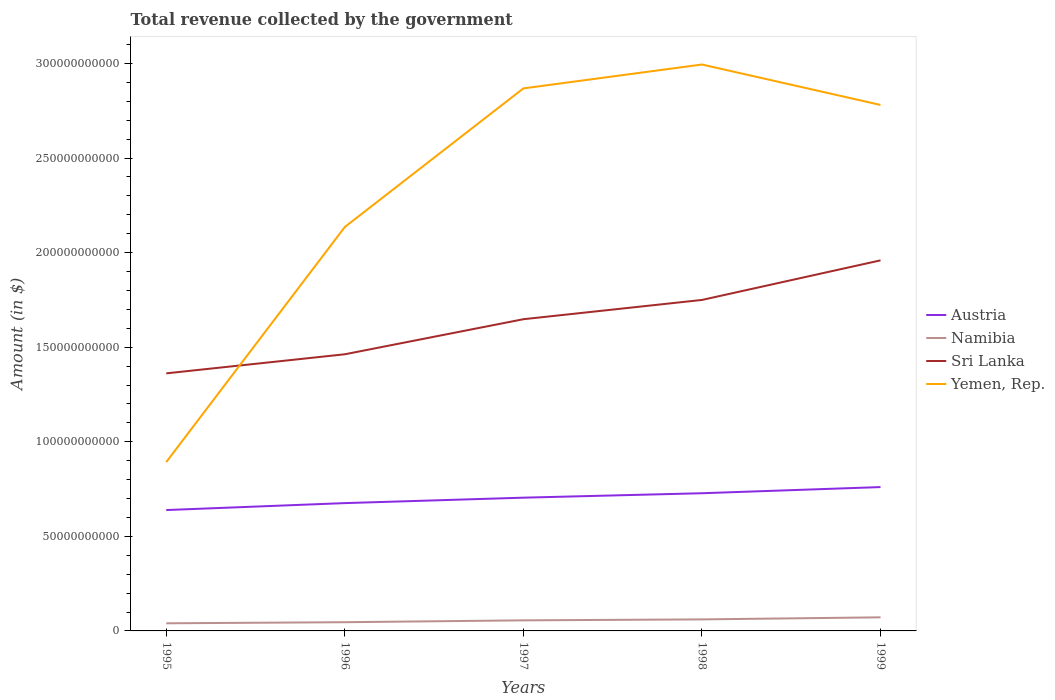How many different coloured lines are there?
Your answer should be very brief. 4. Across all years, what is the maximum total revenue collected by the government in Yemen, Rep.?
Make the answer very short. 8.93e+1. What is the total total revenue collected by the government in Namibia in the graph?
Ensure brevity in your answer.  -9.80e+08. What is the difference between the highest and the second highest total revenue collected by the government in Sri Lanka?
Your answer should be compact. 5.97e+1. How many lines are there?
Your answer should be compact. 4. How many years are there in the graph?
Your response must be concise. 5. What is the difference between two consecutive major ticks on the Y-axis?
Provide a succinct answer. 5.00e+1. Are the values on the major ticks of Y-axis written in scientific E-notation?
Provide a short and direct response. No. Does the graph contain grids?
Your answer should be compact. No. Where does the legend appear in the graph?
Provide a succinct answer. Center right. How are the legend labels stacked?
Your answer should be compact. Vertical. What is the title of the graph?
Your response must be concise. Total revenue collected by the government. What is the label or title of the X-axis?
Your answer should be very brief. Years. What is the label or title of the Y-axis?
Offer a terse response. Amount (in $). What is the Amount (in $) of Austria in 1995?
Offer a very short reply. 6.39e+1. What is the Amount (in $) of Namibia in 1995?
Your answer should be very brief. 4.03e+09. What is the Amount (in $) of Sri Lanka in 1995?
Offer a very short reply. 1.36e+11. What is the Amount (in $) in Yemen, Rep. in 1995?
Make the answer very short. 8.93e+1. What is the Amount (in $) in Austria in 1996?
Offer a very short reply. 6.76e+1. What is the Amount (in $) in Namibia in 1996?
Offer a terse response. 4.61e+09. What is the Amount (in $) of Sri Lanka in 1996?
Give a very brief answer. 1.46e+11. What is the Amount (in $) of Yemen, Rep. in 1996?
Provide a succinct answer. 2.14e+11. What is the Amount (in $) of Austria in 1997?
Provide a succinct answer. 7.04e+1. What is the Amount (in $) in Namibia in 1997?
Ensure brevity in your answer.  5.59e+09. What is the Amount (in $) of Sri Lanka in 1997?
Your answer should be very brief. 1.65e+11. What is the Amount (in $) of Yemen, Rep. in 1997?
Your answer should be very brief. 2.87e+11. What is the Amount (in $) in Austria in 1998?
Your answer should be compact. 7.28e+1. What is the Amount (in $) of Namibia in 1998?
Your answer should be compact. 6.09e+09. What is the Amount (in $) of Sri Lanka in 1998?
Provide a succinct answer. 1.75e+11. What is the Amount (in $) in Yemen, Rep. in 1998?
Offer a very short reply. 2.99e+11. What is the Amount (in $) in Austria in 1999?
Give a very brief answer. 7.60e+1. What is the Amount (in $) in Namibia in 1999?
Provide a short and direct response. 7.18e+09. What is the Amount (in $) in Sri Lanka in 1999?
Give a very brief answer. 1.96e+11. What is the Amount (in $) of Yemen, Rep. in 1999?
Provide a short and direct response. 2.78e+11. Across all years, what is the maximum Amount (in $) of Austria?
Ensure brevity in your answer.  7.60e+1. Across all years, what is the maximum Amount (in $) of Namibia?
Provide a short and direct response. 7.18e+09. Across all years, what is the maximum Amount (in $) of Sri Lanka?
Offer a very short reply. 1.96e+11. Across all years, what is the maximum Amount (in $) of Yemen, Rep.?
Provide a succinct answer. 2.99e+11. Across all years, what is the minimum Amount (in $) in Austria?
Keep it short and to the point. 6.39e+1. Across all years, what is the minimum Amount (in $) of Namibia?
Keep it short and to the point. 4.03e+09. Across all years, what is the minimum Amount (in $) in Sri Lanka?
Give a very brief answer. 1.36e+11. Across all years, what is the minimum Amount (in $) of Yemen, Rep.?
Keep it short and to the point. 8.93e+1. What is the total Amount (in $) in Austria in the graph?
Ensure brevity in your answer.  3.51e+11. What is the total Amount (in $) of Namibia in the graph?
Make the answer very short. 2.75e+1. What is the total Amount (in $) of Sri Lanka in the graph?
Provide a succinct answer. 8.18e+11. What is the total Amount (in $) in Yemen, Rep. in the graph?
Your answer should be very brief. 1.17e+12. What is the difference between the Amount (in $) of Austria in 1995 and that in 1996?
Provide a succinct answer. -3.67e+09. What is the difference between the Amount (in $) of Namibia in 1995 and that in 1996?
Give a very brief answer. -5.83e+08. What is the difference between the Amount (in $) in Sri Lanka in 1995 and that in 1996?
Offer a terse response. -1.01e+1. What is the difference between the Amount (in $) of Yemen, Rep. in 1995 and that in 1996?
Your response must be concise. -1.24e+11. What is the difference between the Amount (in $) of Austria in 1995 and that in 1997?
Your response must be concise. -6.54e+09. What is the difference between the Amount (in $) in Namibia in 1995 and that in 1997?
Keep it short and to the point. -1.56e+09. What is the difference between the Amount (in $) in Sri Lanka in 1995 and that in 1997?
Make the answer very short. -2.86e+1. What is the difference between the Amount (in $) in Yemen, Rep. in 1995 and that in 1997?
Make the answer very short. -1.98e+11. What is the difference between the Amount (in $) of Austria in 1995 and that in 1998?
Your answer should be very brief. -8.89e+09. What is the difference between the Amount (in $) of Namibia in 1995 and that in 1998?
Your response must be concise. -2.07e+09. What is the difference between the Amount (in $) in Sri Lanka in 1995 and that in 1998?
Keep it short and to the point. -3.88e+1. What is the difference between the Amount (in $) of Yemen, Rep. in 1995 and that in 1998?
Ensure brevity in your answer.  -2.10e+11. What is the difference between the Amount (in $) in Austria in 1995 and that in 1999?
Keep it short and to the point. -1.21e+1. What is the difference between the Amount (in $) of Namibia in 1995 and that in 1999?
Offer a very short reply. -3.16e+09. What is the difference between the Amount (in $) of Sri Lanka in 1995 and that in 1999?
Your answer should be compact. -5.97e+1. What is the difference between the Amount (in $) of Yemen, Rep. in 1995 and that in 1999?
Offer a terse response. -1.89e+11. What is the difference between the Amount (in $) of Austria in 1996 and that in 1997?
Your answer should be very brief. -2.87e+09. What is the difference between the Amount (in $) of Namibia in 1996 and that in 1997?
Keep it short and to the point. -9.80e+08. What is the difference between the Amount (in $) of Sri Lanka in 1996 and that in 1997?
Your response must be concise. -1.85e+1. What is the difference between the Amount (in $) in Yemen, Rep. in 1996 and that in 1997?
Keep it short and to the point. -7.33e+1. What is the difference between the Amount (in $) in Austria in 1996 and that in 1998?
Provide a succinct answer. -5.22e+09. What is the difference between the Amount (in $) in Namibia in 1996 and that in 1998?
Your answer should be very brief. -1.48e+09. What is the difference between the Amount (in $) of Sri Lanka in 1996 and that in 1998?
Offer a very short reply. -2.87e+1. What is the difference between the Amount (in $) in Yemen, Rep. in 1996 and that in 1998?
Provide a short and direct response. -8.59e+1. What is the difference between the Amount (in $) of Austria in 1996 and that in 1999?
Ensure brevity in your answer.  -8.47e+09. What is the difference between the Amount (in $) in Namibia in 1996 and that in 1999?
Provide a short and direct response. -2.57e+09. What is the difference between the Amount (in $) of Sri Lanka in 1996 and that in 1999?
Give a very brief answer. -4.96e+1. What is the difference between the Amount (in $) in Yemen, Rep. in 1996 and that in 1999?
Provide a short and direct response. -6.45e+1. What is the difference between the Amount (in $) in Austria in 1997 and that in 1998?
Give a very brief answer. -2.35e+09. What is the difference between the Amount (in $) of Namibia in 1997 and that in 1998?
Provide a succinct answer. -5.03e+08. What is the difference between the Amount (in $) in Sri Lanka in 1997 and that in 1998?
Offer a terse response. -1.02e+1. What is the difference between the Amount (in $) in Yemen, Rep. in 1997 and that in 1998?
Give a very brief answer. -1.26e+1. What is the difference between the Amount (in $) in Austria in 1997 and that in 1999?
Keep it short and to the point. -5.60e+09. What is the difference between the Amount (in $) in Namibia in 1997 and that in 1999?
Provide a short and direct response. -1.59e+09. What is the difference between the Amount (in $) in Sri Lanka in 1997 and that in 1999?
Your answer should be compact. -3.11e+1. What is the difference between the Amount (in $) of Yemen, Rep. in 1997 and that in 1999?
Make the answer very short. 8.75e+09. What is the difference between the Amount (in $) of Austria in 1998 and that in 1999?
Give a very brief answer. -3.25e+09. What is the difference between the Amount (in $) of Namibia in 1998 and that in 1999?
Make the answer very short. -1.09e+09. What is the difference between the Amount (in $) of Sri Lanka in 1998 and that in 1999?
Keep it short and to the point. -2.09e+1. What is the difference between the Amount (in $) of Yemen, Rep. in 1998 and that in 1999?
Keep it short and to the point. 2.14e+1. What is the difference between the Amount (in $) of Austria in 1995 and the Amount (in $) of Namibia in 1996?
Give a very brief answer. 5.93e+1. What is the difference between the Amount (in $) of Austria in 1995 and the Amount (in $) of Sri Lanka in 1996?
Offer a terse response. -8.23e+1. What is the difference between the Amount (in $) in Austria in 1995 and the Amount (in $) in Yemen, Rep. in 1996?
Keep it short and to the point. -1.50e+11. What is the difference between the Amount (in $) in Namibia in 1995 and the Amount (in $) in Sri Lanka in 1996?
Provide a short and direct response. -1.42e+11. What is the difference between the Amount (in $) in Namibia in 1995 and the Amount (in $) in Yemen, Rep. in 1996?
Keep it short and to the point. -2.10e+11. What is the difference between the Amount (in $) of Sri Lanka in 1995 and the Amount (in $) of Yemen, Rep. in 1996?
Give a very brief answer. -7.74e+1. What is the difference between the Amount (in $) of Austria in 1995 and the Amount (in $) of Namibia in 1997?
Make the answer very short. 5.83e+1. What is the difference between the Amount (in $) in Austria in 1995 and the Amount (in $) in Sri Lanka in 1997?
Offer a terse response. -1.01e+11. What is the difference between the Amount (in $) of Austria in 1995 and the Amount (in $) of Yemen, Rep. in 1997?
Provide a short and direct response. -2.23e+11. What is the difference between the Amount (in $) in Namibia in 1995 and the Amount (in $) in Sri Lanka in 1997?
Your response must be concise. -1.61e+11. What is the difference between the Amount (in $) of Namibia in 1995 and the Amount (in $) of Yemen, Rep. in 1997?
Keep it short and to the point. -2.83e+11. What is the difference between the Amount (in $) in Sri Lanka in 1995 and the Amount (in $) in Yemen, Rep. in 1997?
Offer a very short reply. -1.51e+11. What is the difference between the Amount (in $) of Austria in 1995 and the Amount (in $) of Namibia in 1998?
Keep it short and to the point. 5.78e+1. What is the difference between the Amount (in $) in Austria in 1995 and the Amount (in $) in Sri Lanka in 1998?
Your response must be concise. -1.11e+11. What is the difference between the Amount (in $) of Austria in 1995 and the Amount (in $) of Yemen, Rep. in 1998?
Your answer should be compact. -2.36e+11. What is the difference between the Amount (in $) in Namibia in 1995 and the Amount (in $) in Sri Lanka in 1998?
Your answer should be compact. -1.71e+11. What is the difference between the Amount (in $) in Namibia in 1995 and the Amount (in $) in Yemen, Rep. in 1998?
Provide a succinct answer. -2.95e+11. What is the difference between the Amount (in $) of Sri Lanka in 1995 and the Amount (in $) of Yemen, Rep. in 1998?
Provide a succinct answer. -1.63e+11. What is the difference between the Amount (in $) of Austria in 1995 and the Amount (in $) of Namibia in 1999?
Your answer should be very brief. 5.67e+1. What is the difference between the Amount (in $) of Austria in 1995 and the Amount (in $) of Sri Lanka in 1999?
Your answer should be compact. -1.32e+11. What is the difference between the Amount (in $) in Austria in 1995 and the Amount (in $) in Yemen, Rep. in 1999?
Your answer should be very brief. -2.14e+11. What is the difference between the Amount (in $) in Namibia in 1995 and the Amount (in $) in Sri Lanka in 1999?
Provide a short and direct response. -1.92e+11. What is the difference between the Amount (in $) in Namibia in 1995 and the Amount (in $) in Yemen, Rep. in 1999?
Ensure brevity in your answer.  -2.74e+11. What is the difference between the Amount (in $) in Sri Lanka in 1995 and the Amount (in $) in Yemen, Rep. in 1999?
Keep it short and to the point. -1.42e+11. What is the difference between the Amount (in $) in Austria in 1996 and the Amount (in $) in Namibia in 1997?
Provide a succinct answer. 6.20e+1. What is the difference between the Amount (in $) in Austria in 1996 and the Amount (in $) in Sri Lanka in 1997?
Offer a very short reply. -9.72e+1. What is the difference between the Amount (in $) of Austria in 1996 and the Amount (in $) of Yemen, Rep. in 1997?
Provide a succinct answer. -2.19e+11. What is the difference between the Amount (in $) of Namibia in 1996 and the Amount (in $) of Sri Lanka in 1997?
Provide a succinct answer. -1.60e+11. What is the difference between the Amount (in $) in Namibia in 1996 and the Amount (in $) in Yemen, Rep. in 1997?
Offer a very short reply. -2.82e+11. What is the difference between the Amount (in $) in Sri Lanka in 1996 and the Amount (in $) in Yemen, Rep. in 1997?
Offer a very short reply. -1.41e+11. What is the difference between the Amount (in $) of Austria in 1996 and the Amount (in $) of Namibia in 1998?
Provide a succinct answer. 6.15e+1. What is the difference between the Amount (in $) in Austria in 1996 and the Amount (in $) in Sri Lanka in 1998?
Offer a terse response. -1.07e+11. What is the difference between the Amount (in $) of Austria in 1996 and the Amount (in $) of Yemen, Rep. in 1998?
Your response must be concise. -2.32e+11. What is the difference between the Amount (in $) of Namibia in 1996 and the Amount (in $) of Sri Lanka in 1998?
Keep it short and to the point. -1.70e+11. What is the difference between the Amount (in $) of Namibia in 1996 and the Amount (in $) of Yemen, Rep. in 1998?
Keep it short and to the point. -2.95e+11. What is the difference between the Amount (in $) in Sri Lanka in 1996 and the Amount (in $) in Yemen, Rep. in 1998?
Your answer should be compact. -1.53e+11. What is the difference between the Amount (in $) in Austria in 1996 and the Amount (in $) in Namibia in 1999?
Make the answer very short. 6.04e+1. What is the difference between the Amount (in $) in Austria in 1996 and the Amount (in $) in Sri Lanka in 1999?
Ensure brevity in your answer.  -1.28e+11. What is the difference between the Amount (in $) in Austria in 1996 and the Amount (in $) in Yemen, Rep. in 1999?
Give a very brief answer. -2.10e+11. What is the difference between the Amount (in $) of Namibia in 1996 and the Amount (in $) of Sri Lanka in 1999?
Your response must be concise. -1.91e+11. What is the difference between the Amount (in $) of Namibia in 1996 and the Amount (in $) of Yemen, Rep. in 1999?
Keep it short and to the point. -2.73e+11. What is the difference between the Amount (in $) of Sri Lanka in 1996 and the Amount (in $) of Yemen, Rep. in 1999?
Keep it short and to the point. -1.32e+11. What is the difference between the Amount (in $) in Austria in 1997 and the Amount (in $) in Namibia in 1998?
Provide a succinct answer. 6.43e+1. What is the difference between the Amount (in $) of Austria in 1997 and the Amount (in $) of Sri Lanka in 1998?
Provide a succinct answer. -1.05e+11. What is the difference between the Amount (in $) in Austria in 1997 and the Amount (in $) in Yemen, Rep. in 1998?
Offer a very short reply. -2.29e+11. What is the difference between the Amount (in $) of Namibia in 1997 and the Amount (in $) of Sri Lanka in 1998?
Provide a succinct answer. -1.69e+11. What is the difference between the Amount (in $) in Namibia in 1997 and the Amount (in $) in Yemen, Rep. in 1998?
Give a very brief answer. -2.94e+11. What is the difference between the Amount (in $) in Sri Lanka in 1997 and the Amount (in $) in Yemen, Rep. in 1998?
Your answer should be compact. -1.35e+11. What is the difference between the Amount (in $) of Austria in 1997 and the Amount (in $) of Namibia in 1999?
Ensure brevity in your answer.  6.33e+1. What is the difference between the Amount (in $) of Austria in 1997 and the Amount (in $) of Sri Lanka in 1999?
Give a very brief answer. -1.25e+11. What is the difference between the Amount (in $) in Austria in 1997 and the Amount (in $) in Yemen, Rep. in 1999?
Provide a short and direct response. -2.08e+11. What is the difference between the Amount (in $) of Namibia in 1997 and the Amount (in $) of Sri Lanka in 1999?
Offer a very short reply. -1.90e+11. What is the difference between the Amount (in $) in Namibia in 1997 and the Amount (in $) in Yemen, Rep. in 1999?
Your answer should be very brief. -2.72e+11. What is the difference between the Amount (in $) of Sri Lanka in 1997 and the Amount (in $) of Yemen, Rep. in 1999?
Give a very brief answer. -1.13e+11. What is the difference between the Amount (in $) in Austria in 1998 and the Amount (in $) in Namibia in 1999?
Provide a succinct answer. 6.56e+1. What is the difference between the Amount (in $) of Austria in 1998 and the Amount (in $) of Sri Lanka in 1999?
Ensure brevity in your answer.  -1.23e+11. What is the difference between the Amount (in $) of Austria in 1998 and the Amount (in $) of Yemen, Rep. in 1999?
Keep it short and to the point. -2.05e+11. What is the difference between the Amount (in $) in Namibia in 1998 and the Amount (in $) in Sri Lanka in 1999?
Give a very brief answer. -1.90e+11. What is the difference between the Amount (in $) in Namibia in 1998 and the Amount (in $) in Yemen, Rep. in 1999?
Offer a terse response. -2.72e+11. What is the difference between the Amount (in $) of Sri Lanka in 1998 and the Amount (in $) of Yemen, Rep. in 1999?
Your answer should be very brief. -1.03e+11. What is the average Amount (in $) of Austria per year?
Offer a very short reply. 7.01e+1. What is the average Amount (in $) in Namibia per year?
Make the answer very short. 5.50e+09. What is the average Amount (in $) in Sri Lanka per year?
Give a very brief answer. 1.64e+11. What is the average Amount (in $) in Yemen, Rep. per year?
Your answer should be very brief. 2.33e+11. In the year 1995, what is the difference between the Amount (in $) of Austria and Amount (in $) of Namibia?
Ensure brevity in your answer.  5.99e+1. In the year 1995, what is the difference between the Amount (in $) of Austria and Amount (in $) of Sri Lanka?
Ensure brevity in your answer.  -7.23e+1. In the year 1995, what is the difference between the Amount (in $) in Austria and Amount (in $) in Yemen, Rep.?
Your answer should be very brief. -2.54e+1. In the year 1995, what is the difference between the Amount (in $) in Namibia and Amount (in $) in Sri Lanka?
Keep it short and to the point. -1.32e+11. In the year 1995, what is the difference between the Amount (in $) in Namibia and Amount (in $) in Yemen, Rep.?
Your answer should be compact. -8.52e+1. In the year 1995, what is the difference between the Amount (in $) in Sri Lanka and Amount (in $) in Yemen, Rep.?
Ensure brevity in your answer.  4.69e+1. In the year 1996, what is the difference between the Amount (in $) in Austria and Amount (in $) in Namibia?
Make the answer very short. 6.30e+1. In the year 1996, what is the difference between the Amount (in $) of Austria and Amount (in $) of Sri Lanka?
Your response must be concise. -7.87e+1. In the year 1996, what is the difference between the Amount (in $) in Austria and Amount (in $) in Yemen, Rep.?
Your response must be concise. -1.46e+11. In the year 1996, what is the difference between the Amount (in $) of Namibia and Amount (in $) of Sri Lanka?
Provide a succinct answer. -1.42e+11. In the year 1996, what is the difference between the Amount (in $) of Namibia and Amount (in $) of Yemen, Rep.?
Your answer should be very brief. -2.09e+11. In the year 1996, what is the difference between the Amount (in $) of Sri Lanka and Amount (in $) of Yemen, Rep.?
Offer a terse response. -6.73e+1. In the year 1997, what is the difference between the Amount (in $) of Austria and Amount (in $) of Namibia?
Offer a very short reply. 6.48e+1. In the year 1997, what is the difference between the Amount (in $) of Austria and Amount (in $) of Sri Lanka?
Offer a very short reply. -9.43e+1. In the year 1997, what is the difference between the Amount (in $) of Austria and Amount (in $) of Yemen, Rep.?
Your response must be concise. -2.16e+11. In the year 1997, what is the difference between the Amount (in $) in Namibia and Amount (in $) in Sri Lanka?
Offer a very short reply. -1.59e+11. In the year 1997, what is the difference between the Amount (in $) in Namibia and Amount (in $) in Yemen, Rep.?
Provide a short and direct response. -2.81e+11. In the year 1997, what is the difference between the Amount (in $) of Sri Lanka and Amount (in $) of Yemen, Rep.?
Provide a succinct answer. -1.22e+11. In the year 1998, what is the difference between the Amount (in $) in Austria and Amount (in $) in Namibia?
Keep it short and to the point. 6.67e+1. In the year 1998, what is the difference between the Amount (in $) of Austria and Amount (in $) of Sri Lanka?
Keep it short and to the point. -1.02e+11. In the year 1998, what is the difference between the Amount (in $) in Austria and Amount (in $) in Yemen, Rep.?
Keep it short and to the point. -2.27e+11. In the year 1998, what is the difference between the Amount (in $) in Namibia and Amount (in $) in Sri Lanka?
Your answer should be very brief. -1.69e+11. In the year 1998, what is the difference between the Amount (in $) of Namibia and Amount (in $) of Yemen, Rep.?
Make the answer very short. -2.93e+11. In the year 1998, what is the difference between the Amount (in $) of Sri Lanka and Amount (in $) of Yemen, Rep.?
Ensure brevity in your answer.  -1.24e+11. In the year 1999, what is the difference between the Amount (in $) of Austria and Amount (in $) of Namibia?
Offer a terse response. 6.89e+1. In the year 1999, what is the difference between the Amount (in $) of Austria and Amount (in $) of Sri Lanka?
Your answer should be compact. -1.20e+11. In the year 1999, what is the difference between the Amount (in $) in Austria and Amount (in $) in Yemen, Rep.?
Provide a short and direct response. -2.02e+11. In the year 1999, what is the difference between the Amount (in $) of Namibia and Amount (in $) of Sri Lanka?
Keep it short and to the point. -1.89e+11. In the year 1999, what is the difference between the Amount (in $) of Namibia and Amount (in $) of Yemen, Rep.?
Make the answer very short. -2.71e+11. In the year 1999, what is the difference between the Amount (in $) in Sri Lanka and Amount (in $) in Yemen, Rep.?
Give a very brief answer. -8.22e+1. What is the ratio of the Amount (in $) in Austria in 1995 to that in 1996?
Keep it short and to the point. 0.95. What is the ratio of the Amount (in $) of Namibia in 1995 to that in 1996?
Offer a terse response. 0.87. What is the ratio of the Amount (in $) in Sri Lanka in 1995 to that in 1996?
Offer a very short reply. 0.93. What is the ratio of the Amount (in $) of Yemen, Rep. in 1995 to that in 1996?
Provide a short and direct response. 0.42. What is the ratio of the Amount (in $) in Austria in 1995 to that in 1997?
Give a very brief answer. 0.91. What is the ratio of the Amount (in $) of Namibia in 1995 to that in 1997?
Your answer should be compact. 0.72. What is the ratio of the Amount (in $) in Sri Lanka in 1995 to that in 1997?
Ensure brevity in your answer.  0.83. What is the ratio of the Amount (in $) of Yemen, Rep. in 1995 to that in 1997?
Offer a terse response. 0.31. What is the ratio of the Amount (in $) in Austria in 1995 to that in 1998?
Make the answer very short. 0.88. What is the ratio of the Amount (in $) of Namibia in 1995 to that in 1998?
Provide a succinct answer. 0.66. What is the ratio of the Amount (in $) of Sri Lanka in 1995 to that in 1998?
Give a very brief answer. 0.78. What is the ratio of the Amount (in $) of Yemen, Rep. in 1995 to that in 1998?
Your answer should be very brief. 0.3. What is the ratio of the Amount (in $) of Austria in 1995 to that in 1999?
Your answer should be very brief. 0.84. What is the ratio of the Amount (in $) in Namibia in 1995 to that in 1999?
Provide a short and direct response. 0.56. What is the ratio of the Amount (in $) of Sri Lanka in 1995 to that in 1999?
Your response must be concise. 0.7. What is the ratio of the Amount (in $) in Yemen, Rep. in 1995 to that in 1999?
Ensure brevity in your answer.  0.32. What is the ratio of the Amount (in $) in Austria in 1996 to that in 1997?
Offer a very short reply. 0.96. What is the ratio of the Amount (in $) in Namibia in 1996 to that in 1997?
Your response must be concise. 0.82. What is the ratio of the Amount (in $) of Sri Lanka in 1996 to that in 1997?
Offer a terse response. 0.89. What is the ratio of the Amount (in $) in Yemen, Rep. in 1996 to that in 1997?
Make the answer very short. 0.74. What is the ratio of the Amount (in $) of Austria in 1996 to that in 1998?
Your response must be concise. 0.93. What is the ratio of the Amount (in $) in Namibia in 1996 to that in 1998?
Offer a terse response. 0.76. What is the ratio of the Amount (in $) in Sri Lanka in 1996 to that in 1998?
Your answer should be very brief. 0.84. What is the ratio of the Amount (in $) in Yemen, Rep. in 1996 to that in 1998?
Your answer should be very brief. 0.71. What is the ratio of the Amount (in $) of Austria in 1996 to that in 1999?
Your answer should be very brief. 0.89. What is the ratio of the Amount (in $) in Namibia in 1996 to that in 1999?
Your answer should be compact. 0.64. What is the ratio of the Amount (in $) in Sri Lanka in 1996 to that in 1999?
Provide a short and direct response. 0.75. What is the ratio of the Amount (in $) in Yemen, Rep. in 1996 to that in 1999?
Provide a succinct answer. 0.77. What is the ratio of the Amount (in $) of Austria in 1997 to that in 1998?
Your answer should be compact. 0.97. What is the ratio of the Amount (in $) in Namibia in 1997 to that in 1998?
Make the answer very short. 0.92. What is the ratio of the Amount (in $) in Sri Lanka in 1997 to that in 1998?
Give a very brief answer. 0.94. What is the ratio of the Amount (in $) of Yemen, Rep. in 1997 to that in 1998?
Your answer should be compact. 0.96. What is the ratio of the Amount (in $) in Austria in 1997 to that in 1999?
Offer a very short reply. 0.93. What is the ratio of the Amount (in $) in Namibia in 1997 to that in 1999?
Offer a very short reply. 0.78. What is the ratio of the Amount (in $) of Sri Lanka in 1997 to that in 1999?
Provide a short and direct response. 0.84. What is the ratio of the Amount (in $) in Yemen, Rep. in 1997 to that in 1999?
Your answer should be very brief. 1.03. What is the ratio of the Amount (in $) in Austria in 1998 to that in 1999?
Give a very brief answer. 0.96. What is the ratio of the Amount (in $) in Namibia in 1998 to that in 1999?
Your answer should be very brief. 0.85. What is the ratio of the Amount (in $) in Sri Lanka in 1998 to that in 1999?
Make the answer very short. 0.89. What is the ratio of the Amount (in $) of Yemen, Rep. in 1998 to that in 1999?
Offer a terse response. 1.08. What is the difference between the highest and the second highest Amount (in $) in Austria?
Give a very brief answer. 3.25e+09. What is the difference between the highest and the second highest Amount (in $) of Namibia?
Make the answer very short. 1.09e+09. What is the difference between the highest and the second highest Amount (in $) in Sri Lanka?
Offer a very short reply. 2.09e+1. What is the difference between the highest and the second highest Amount (in $) in Yemen, Rep.?
Give a very brief answer. 1.26e+1. What is the difference between the highest and the lowest Amount (in $) in Austria?
Give a very brief answer. 1.21e+1. What is the difference between the highest and the lowest Amount (in $) in Namibia?
Keep it short and to the point. 3.16e+09. What is the difference between the highest and the lowest Amount (in $) of Sri Lanka?
Your answer should be compact. 5.97e+1. What is the difference between the highest and the lowest Amount (in $) of Yemen, Rep.?
Ensure brevity in your answer.  2.10e+11. 